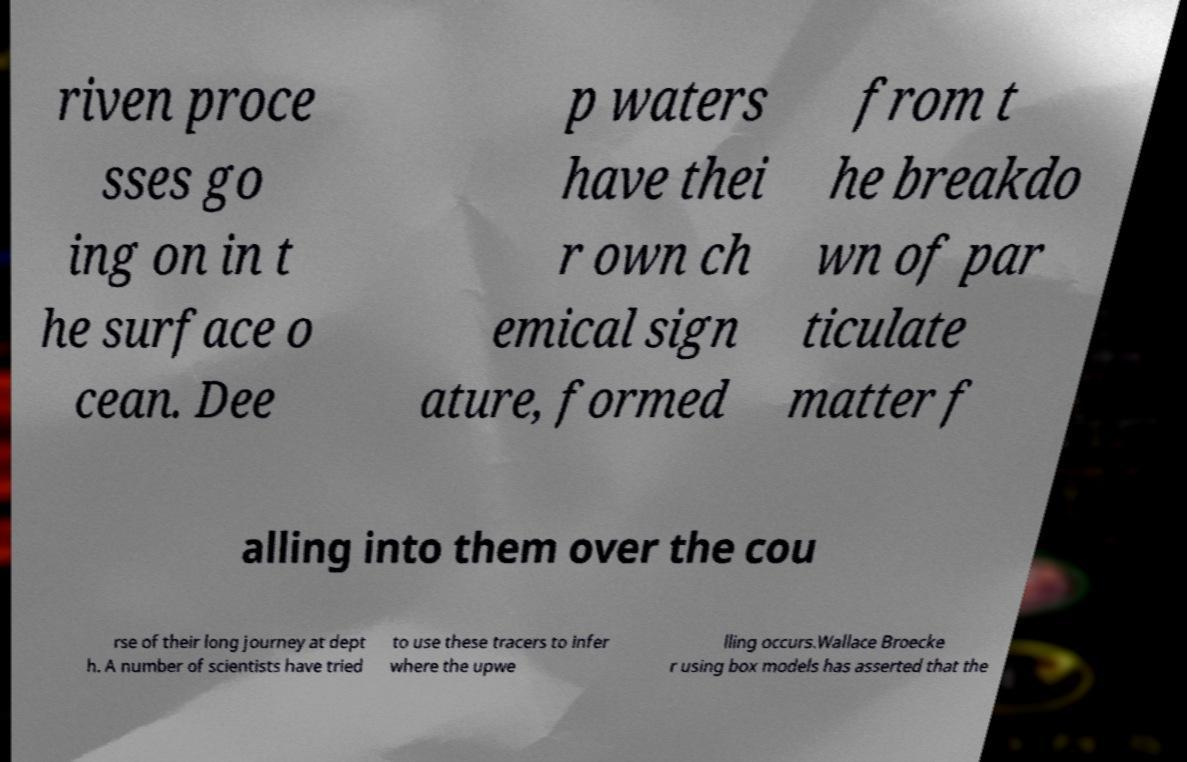Please read and relay the text visible in this image. What does it say? riven proce sses go ing on in t he surface o cean. Dee p waters have thei r own ch emical sign ature, formed from t he breakdo wn of par ticulate matter f alling into them over the cou rse of their long journey at dept h. A number of scientists have tried to use these tracers to infer where the upwe lling occurs.Wallace Broecke r using box models has asserted that the 